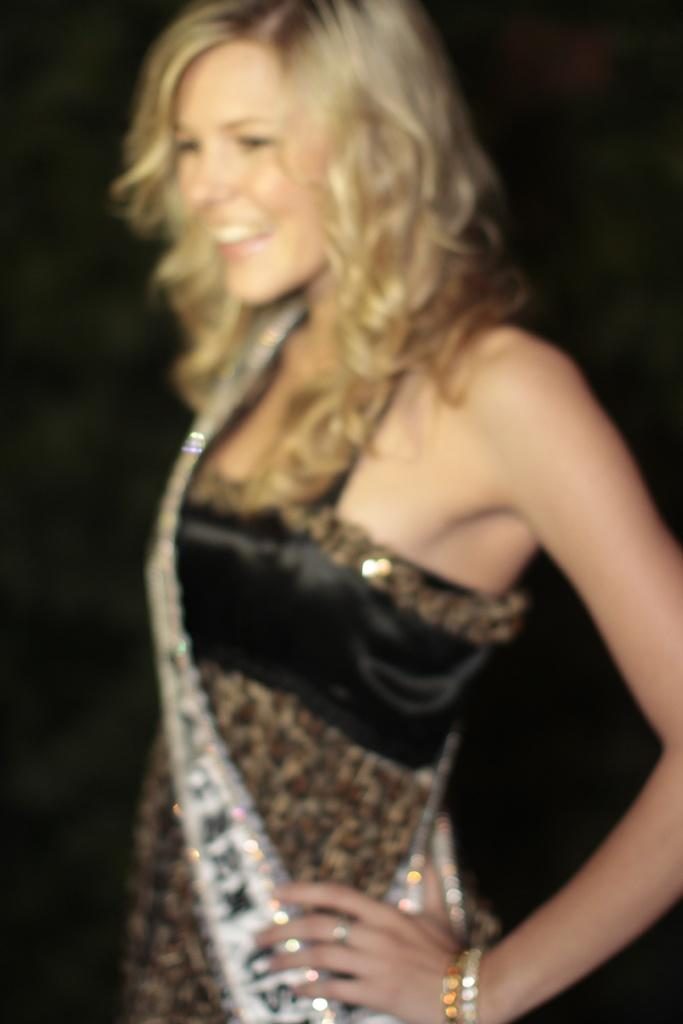Who is present in the image? There is a woman in the image. What is the woman doing in the image? The woman is standing in the image. In which direction is the woman facing? The woman is facing towards the left side. What is the expression on the woman's face? The woman is smiling in the image. What color is the background of the image? The background of the image is black. What type of oil can be seen dripping from the woman's hair in the image? There is no oil or any dripping substance visible in the woman's hair in the image. 